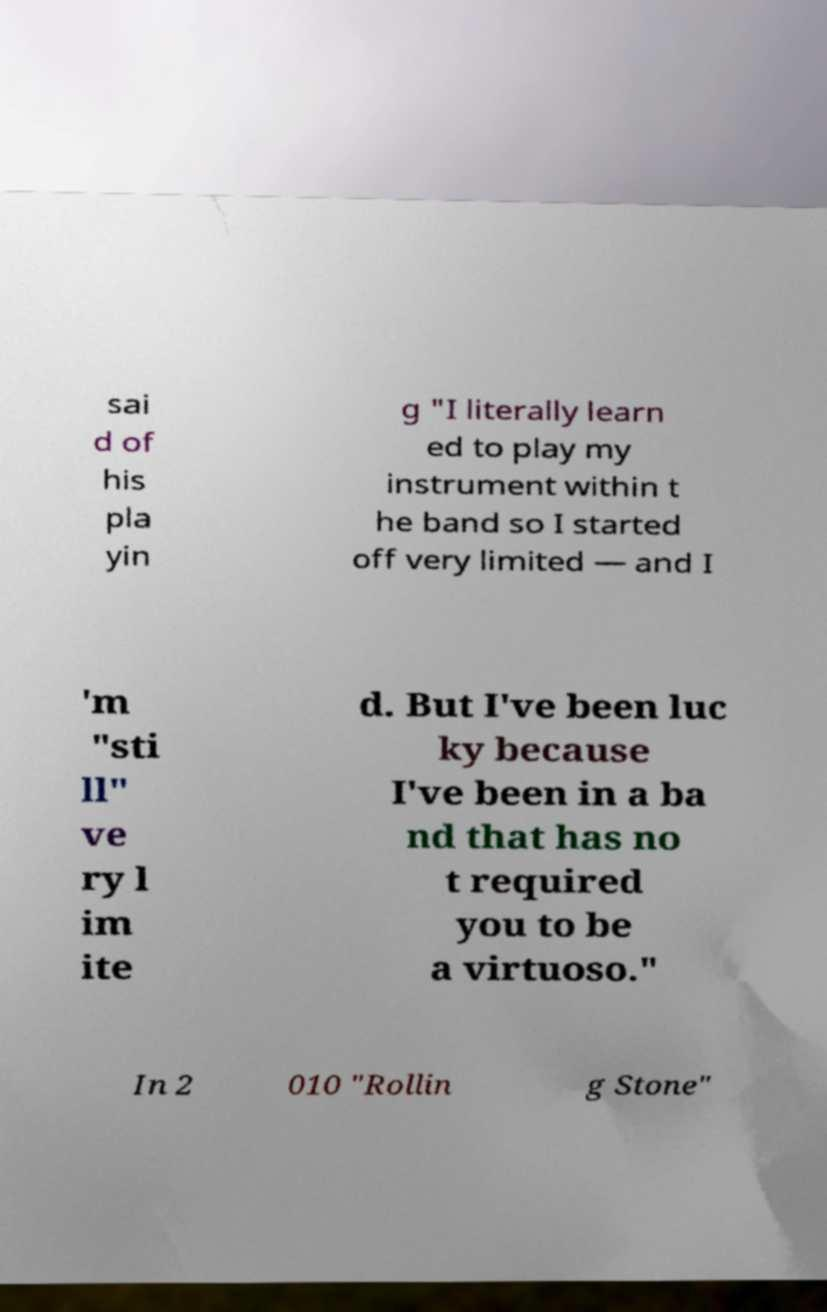For documentation purposes, I need the text within this image transcribed. Could you provide that? sai d of his pla yin g "I literally learn ed to play my instrument within t he band so I started off very limited — and I 'm "sti ll" ve ry l im ite d. But I've been luc ky because I've been in a ba nd that has no t required you to be a virtuoso." In 2 010 "Rollin g Stone" 